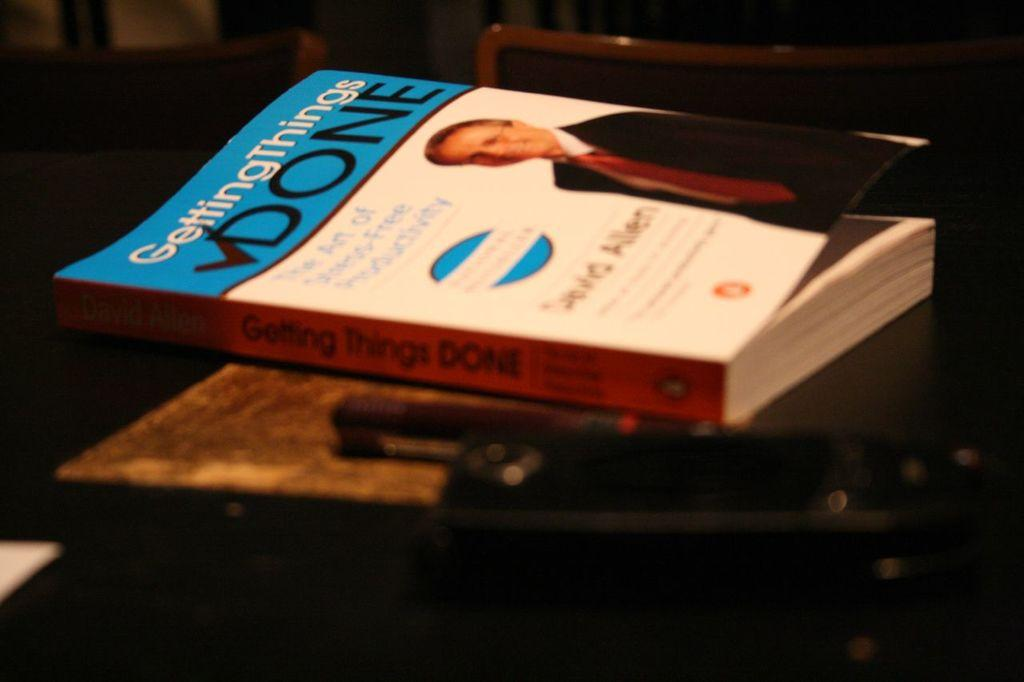<image>
Present a compact description of the photo's key features. a book titled Getting Things Done with a person on it 